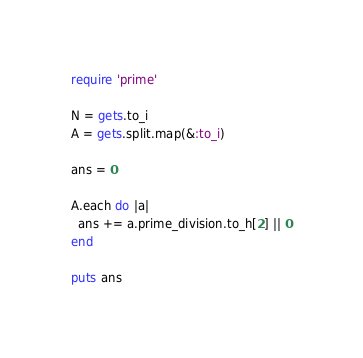<code> <loc_0><loc_0><loc_500><loc_500><_Ruby_>require 'prime'

N = gets.to_i
A = gets.split.map(&:to_i)

ans = 0

A.each do |a|
  ans += a.prime_division.to_h[2] || 0
end

puts ans
</code> 